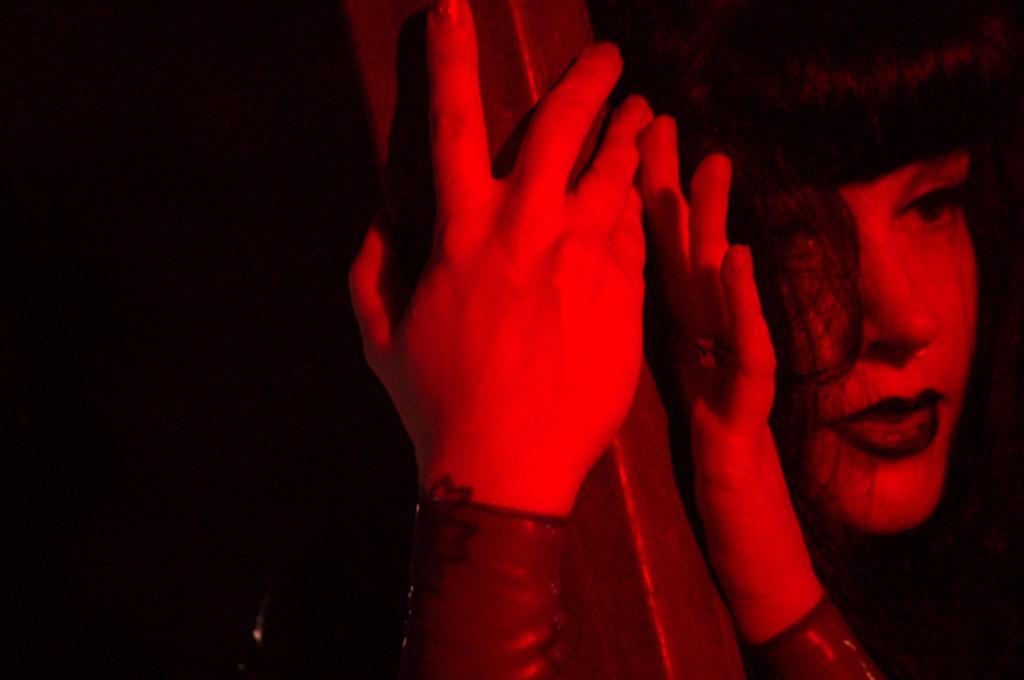In one or two sentences, can you explain what this image depicts? In this picture we can see a person. 